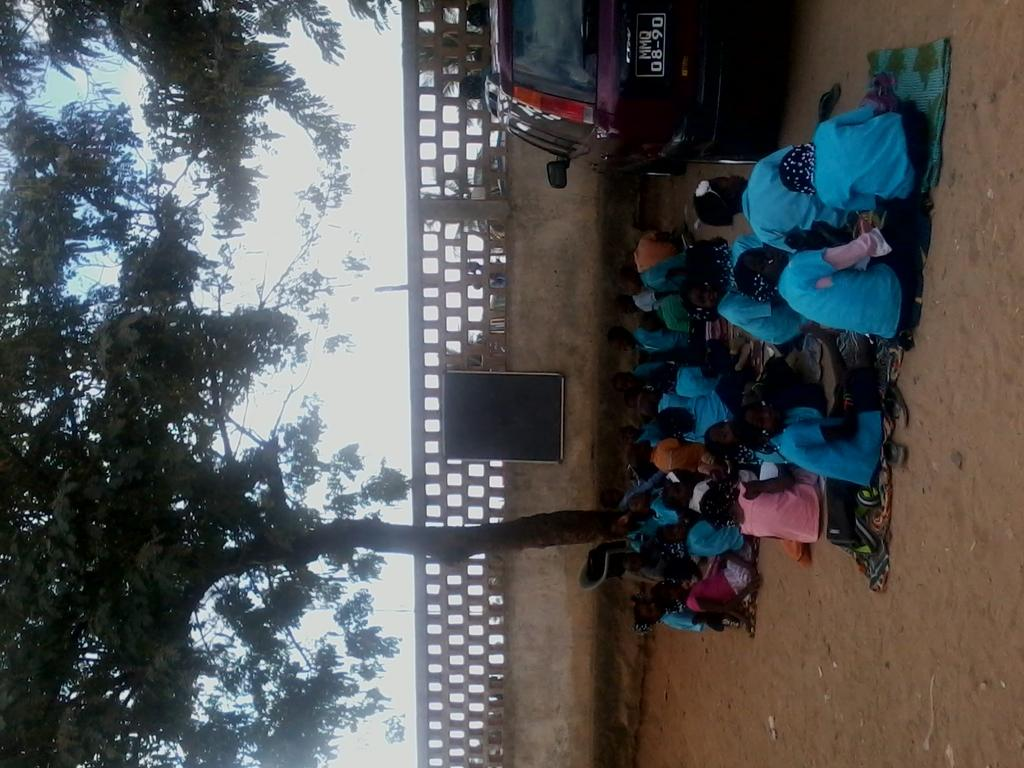What are the children doing in the image? The children are sitting under the trees. What can be seen on the compound wall in the image? There is a blackboard on the compound wall. What type of object with a number plate is visible in the image? A vehicle with a number plate is visible in the image. What type of cloth is being used to make popcorn in the image? There is no cloth or popcorn present in the image. What color is the vest worn by the children in the image? The provided facts do not mention any clothing worn by the children, so we cannot determine the color of a vest. 